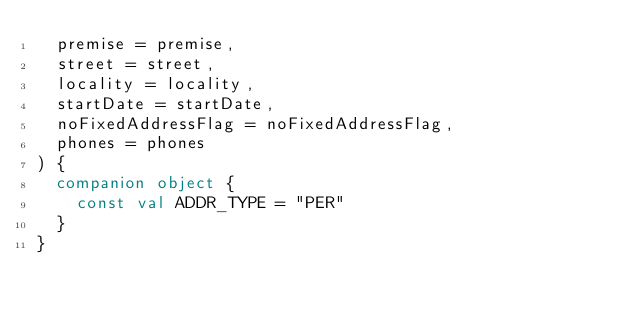<code> <loc_0><loc_0><loc_500><loc_500><_Kotlin_>  premise = premise,
  street = street,
  locality = locality,
  startDate = startDate,
  noFixedAddressFlag = noFixedAddressFlag,
  phones = phones
) {
  companion object {
    const val ADDR_TYPE = "PER"
  }
}
</code> 